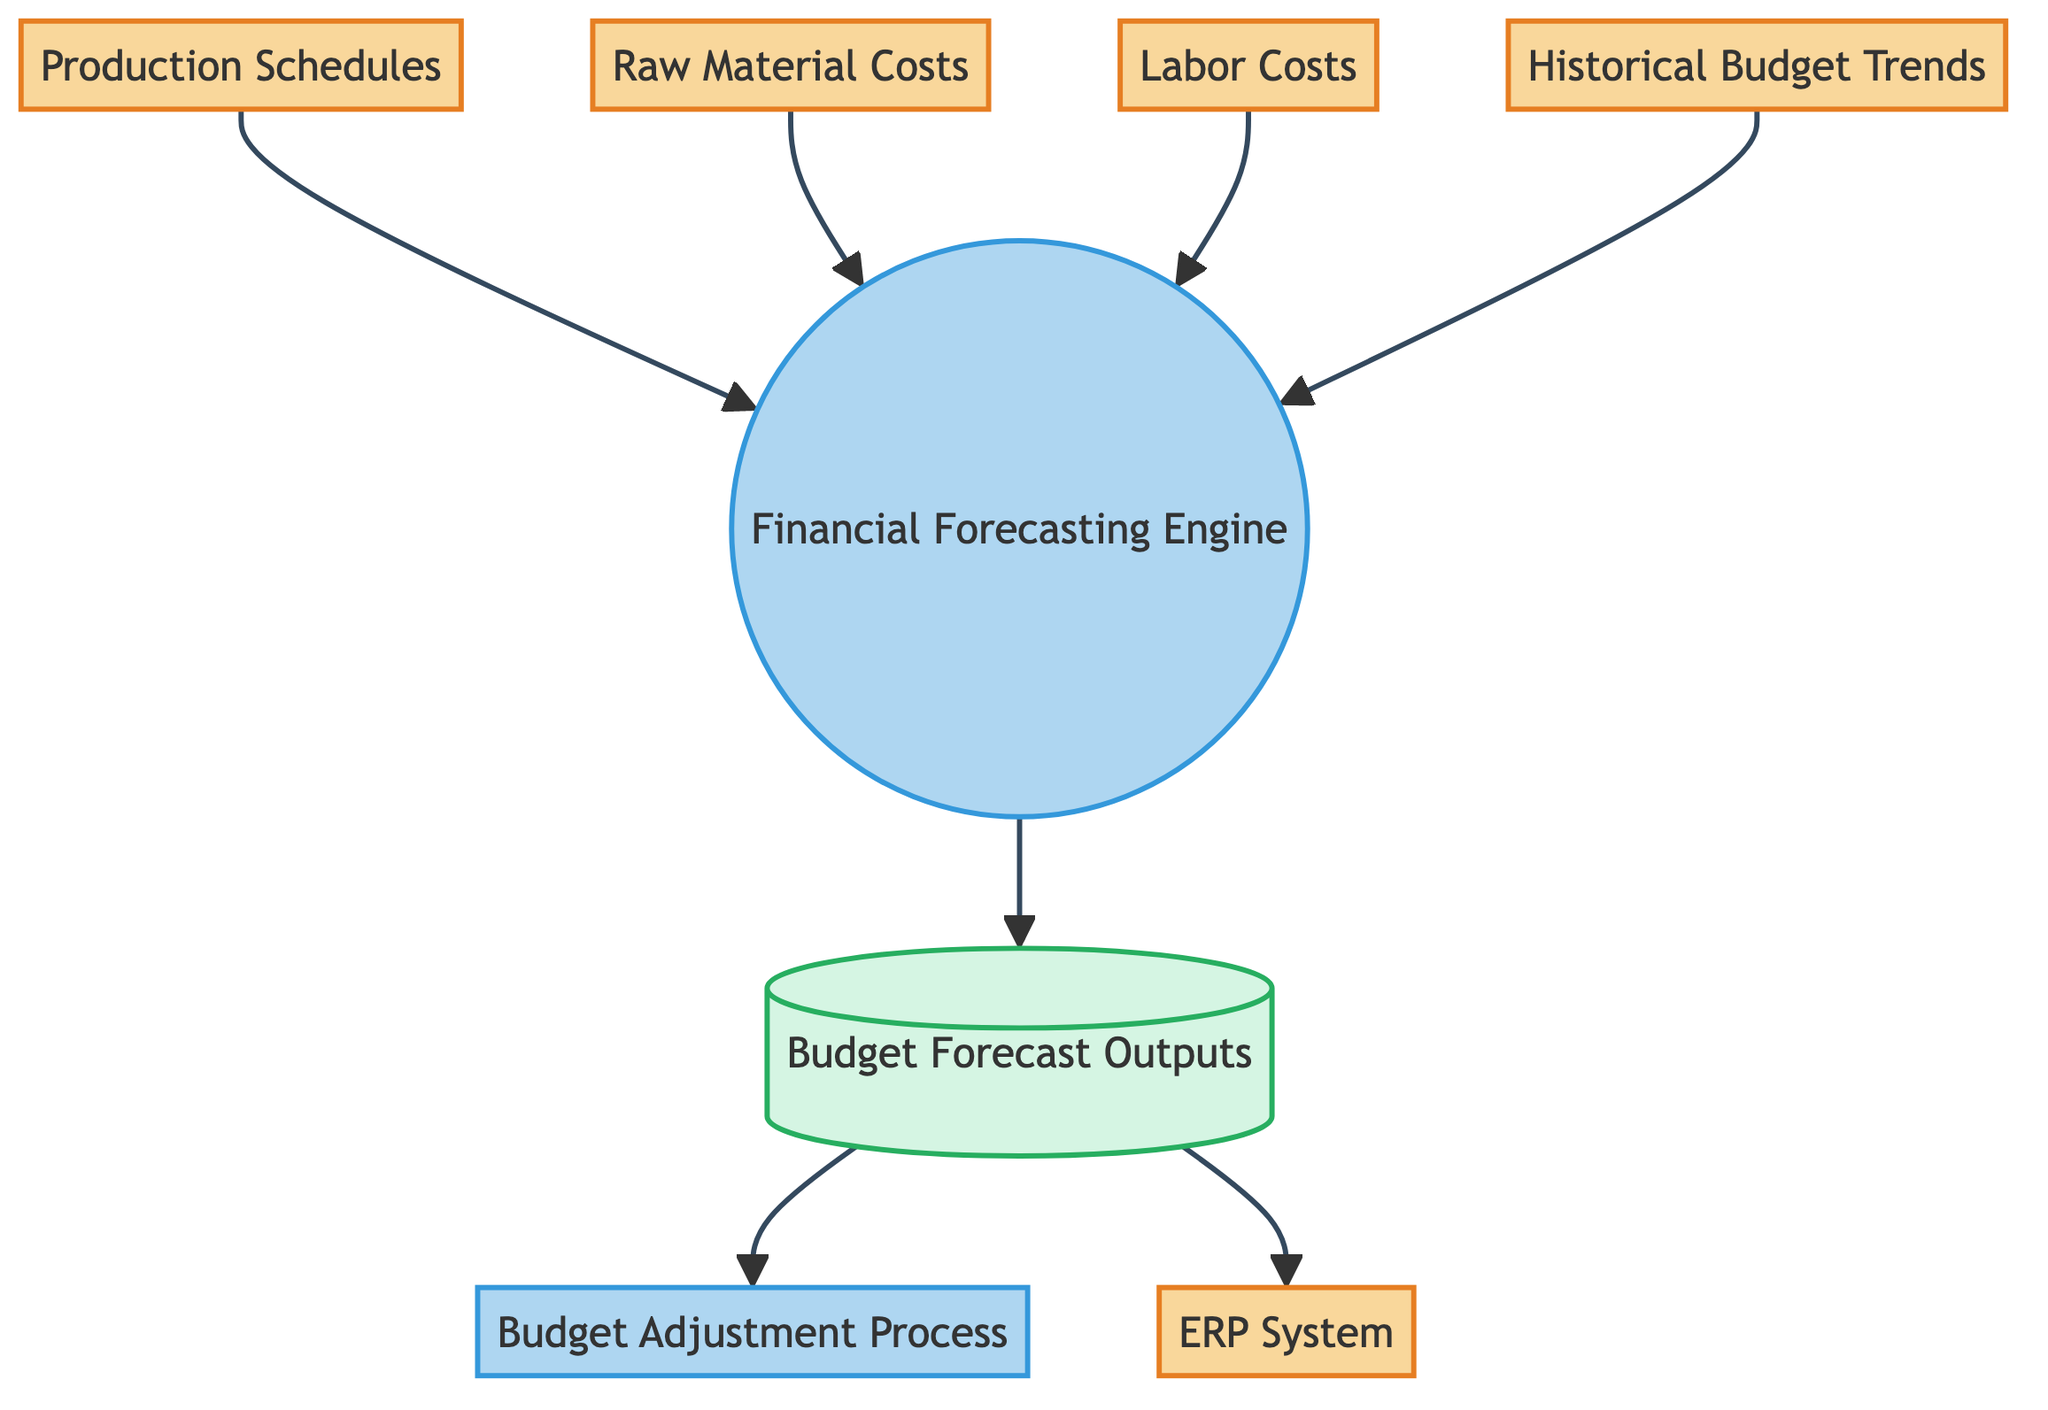What are the data sources for the Financial Forecasting Engine? The diagram shows four data sources feeding into the Financial Forecasting Engine: Production Schedules, Raw Material Costs, Labor Costs, and Historical Budget Trends.
Answer: Production Schedules, Raw Material Costs, Labor Costs, Historical Budget Trends How many processes are represented in the diagram? The diagram contains two processes: the Financial Forecasting Engine and the Budget Adjustment Process. Each of these is labeled distinctly as a process node.
Answer: 2 What does the Budget Forecast Outputs store? It stores data generated by the Financial Forecasting Engine, which includes the budget forecasts for the manufacturing units. This is indicated by the arrows representing outgoing connections from the Financial Forecasting Engine to the Budget Forecast Outputs.
Answer: Budget forecasts What is the relationship between the Budget Forecast Outputs and the ERP System? The ERP System receives inputs from the Budget Forecast Outputs, which means that the ERP System can utilize the generated budget forecasts for resource planning and management.
Answer: Input Which external entities provide data inputs to the Financial Forecasting Engine? The external entities providing data inputs are Production Schedules, Raw Material Costs, Labor Costs, and Historical Budget Trends as indicated by the directed arrows leading to the Financial Forecasting Engine.
Answer: Production Schedules, Raw Material Costs, Labor Costs, Historical Budget Trends What will happen to the Budget Forecast Outputs after they are generated? The Budget Forecast Outputs are used as inputs for both the Budget Adjustment Process and the ERP System, suggesting their role in adjusting budgets and managing resources further along in the process flow.
Answer: Used in Budget Adjustment Process and ERP System Which component is responsible for aggregating the data inputs? The Financial Forecasting Engine is responsible for aggregating all the inputs to create budget forecasts, as specified in the process description.
Answer: Financial Forecasting Engine What type of diagram is this? This is a Data Flow Diagram, which represents the flow of information and processes involved in budget allocation planning for manufacturing units.
Answer: Data Flow Diagram 